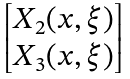<formula> <loc_0><loc_0><loc_500><loc_500>\begin{bmatrix} X _ { 2 } ( x , \xi ) \\ X _ { 3 } ( x , \xi ) \end{bmatrix}</formula> 